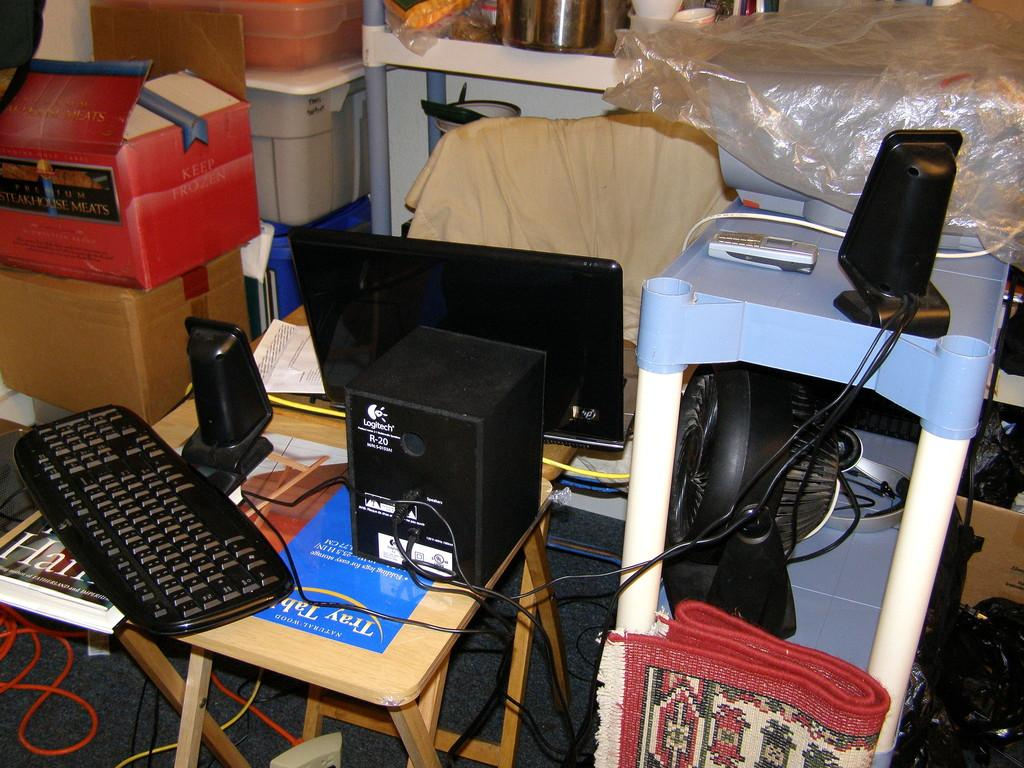What is the main subject of the image? The main subject of the image is a system. What is located on the table in the image? There is a sound box on the table in the image. What type of containers are present in the image? There are cardboard boxes and baskets in the image. What type of wave can be seen crashing on the shore in the image? There is no wave or shore present in the image; it features a system, a sound box, cardboard boxes, and baskets. How many eggs are visible in the image? There are no eggs present in the image. 